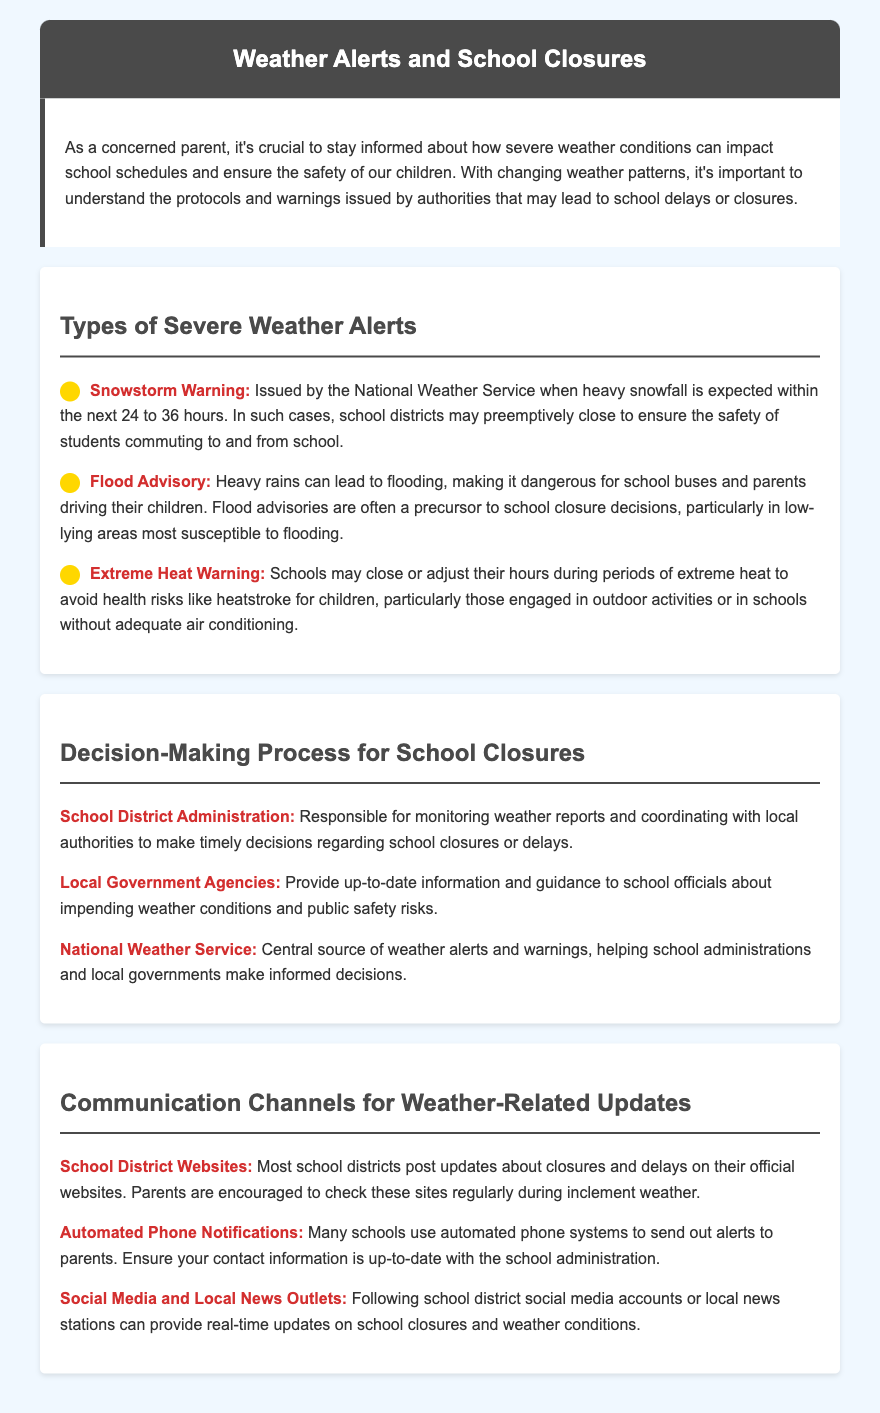What is issued when heavy snowfall is expected? The document states that a Snowstorm Warning is issued by the National Weather Service when heavy snowfall is expected.
Answer: Snowstorm Warning Who is responsible for monitoring weather reports? The document specifies that the School District Administration is responsible for monitoring weather reports and coordinating with local authorities.
Answer: School District Administration What might lead to a school closure in low-lying areas? The document mentions that a Flood Advisory can make it dangerous and may lead to school closure decisions, particularly in low-lying areas.
Answer: Flood Advisory Which social media tool can provide real-time updates on school closures? The document indicates that following school district social media accounts can provide real-time updates on school closures and weather conditions.
Answer: Social Media What health risk is associated with extreme heat in schools? The document outlines that extreme heat can lead to health risks like heatstroke for children, especially those engaged in outdoor activities.
Answer: Heatstroke What is the primary source for weather alerts and warnings? According to the document, the National Weather Service is the central source of weather alerts and warnings.
Answer: National Weather Service Which method do schools use to send automated alerts to parents? The document states that many schools use automated phone systems to send out alerts to parents about weather-related updates.
Answer: Automated Phone Notifications What is the purpose of the intro section? The document explains that the intro section emphasizes the importance of staying informed about weather impacts on school schedules for child safety.
Answer: Child safety 